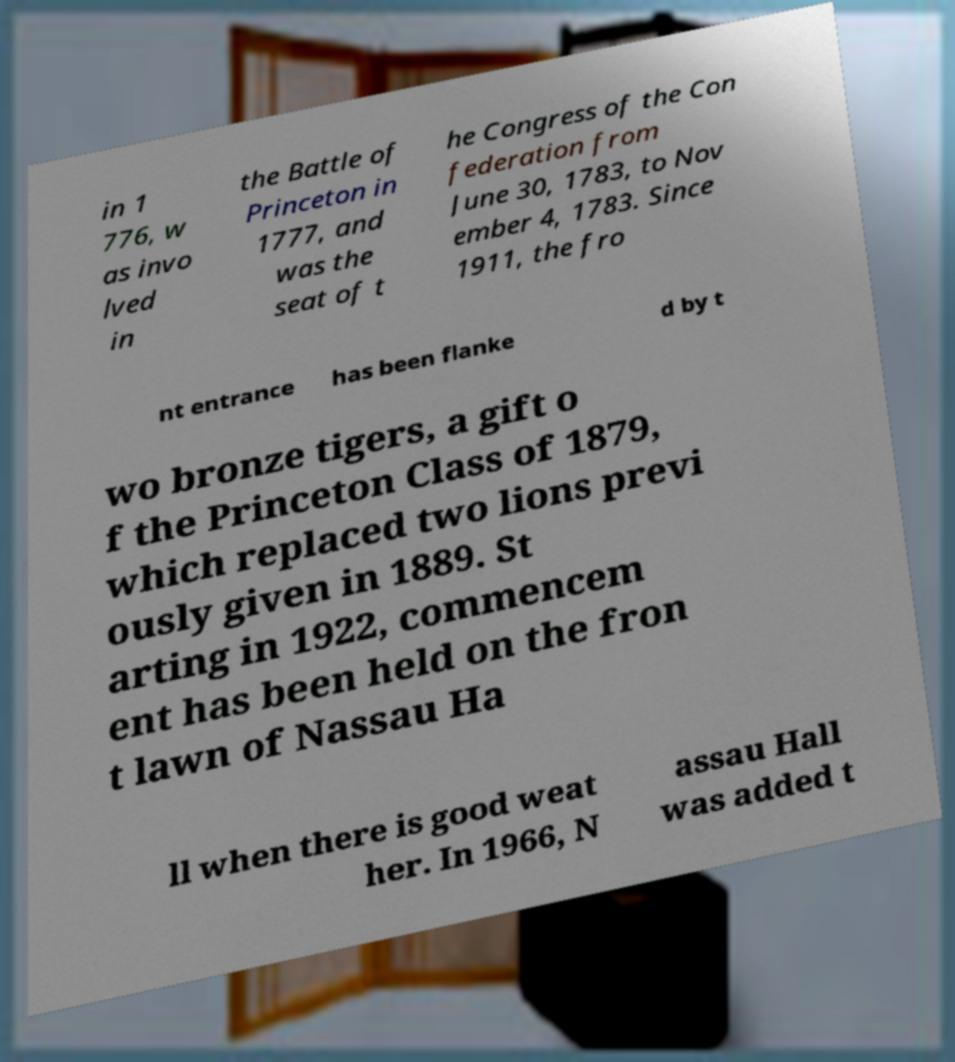Could you assist in decoding the text presented in this image and type it out clearly? in 1 776, w as invo lved in the Battle of Princeton in 1777, and was the seat of t he Congress of the Con federation from June 30, 1783, to Nov ember 4, 1783. Since 1911, the fro nt entrance has been flanke d by t wo bronze tigers, a gift o f the Princeton Class of 1879, which replaced two lions previ ously given in 1889. St arting in 1922, commencem ent has been held on the fron t lawn of Nassau Ha ll when there is good weat her. In 1966, N assau Hall was added t 